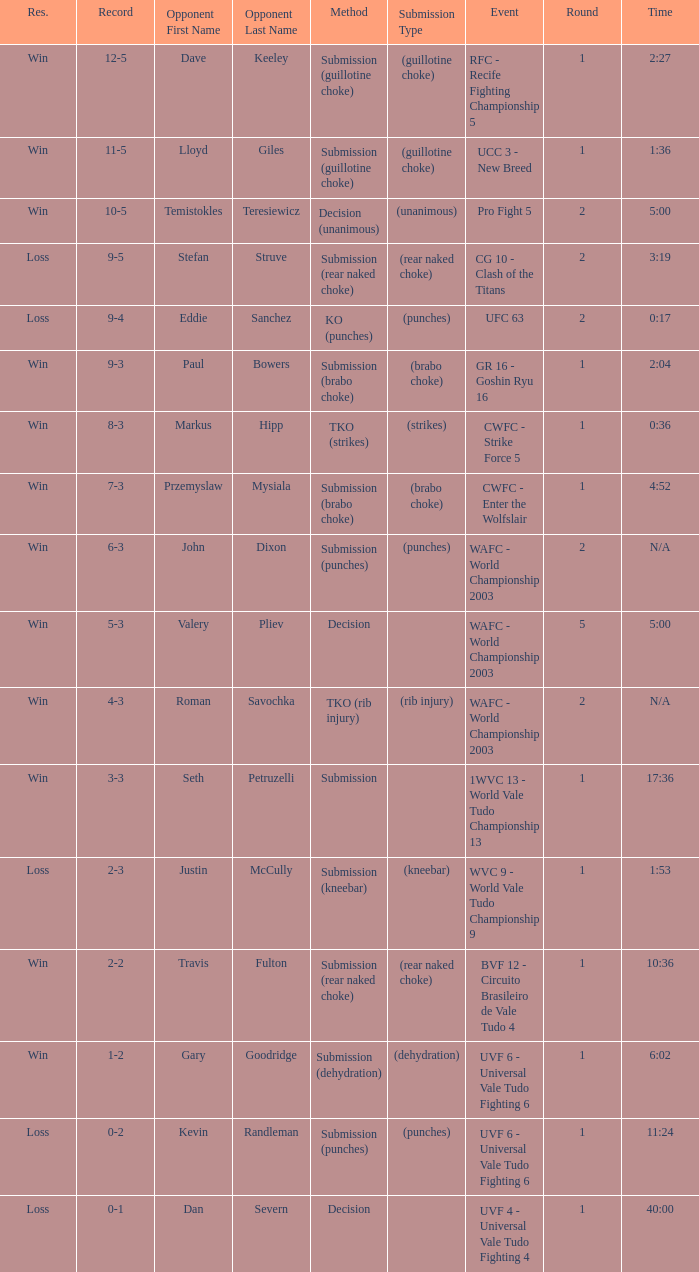What opponent uses the method of decision and a 5-3 record? Valery Pliev. 